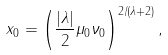Convert formula to latex. <formula><loc_0><loc_0><loc_500><loc_500>x _ { 0 } = \left ( \frac { | \lambda | } { 2 } \mu _ { 0 } \nu _ { 0 } \right ) ^ { 2 / ( \lambda + 2 ) } ,</formula> 